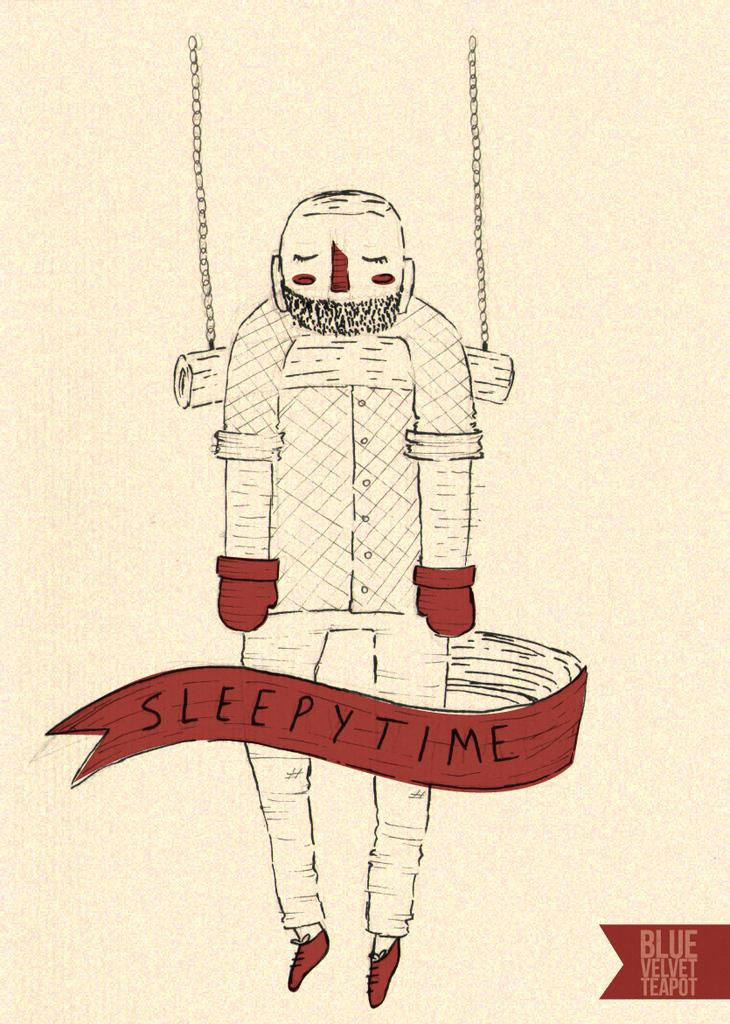What is the main subject of the image? The main subject of the image is a sketch of a person. What else can be seen in the image besides the sketch? There is text visible in the image. What type of trail can be seen in the image? There is no trail present in the image; it features a sketch of a person and text. What is the opinion of the person in the image about amusement parks? The image does not provide any information about the person's opinion on amusement parks. 